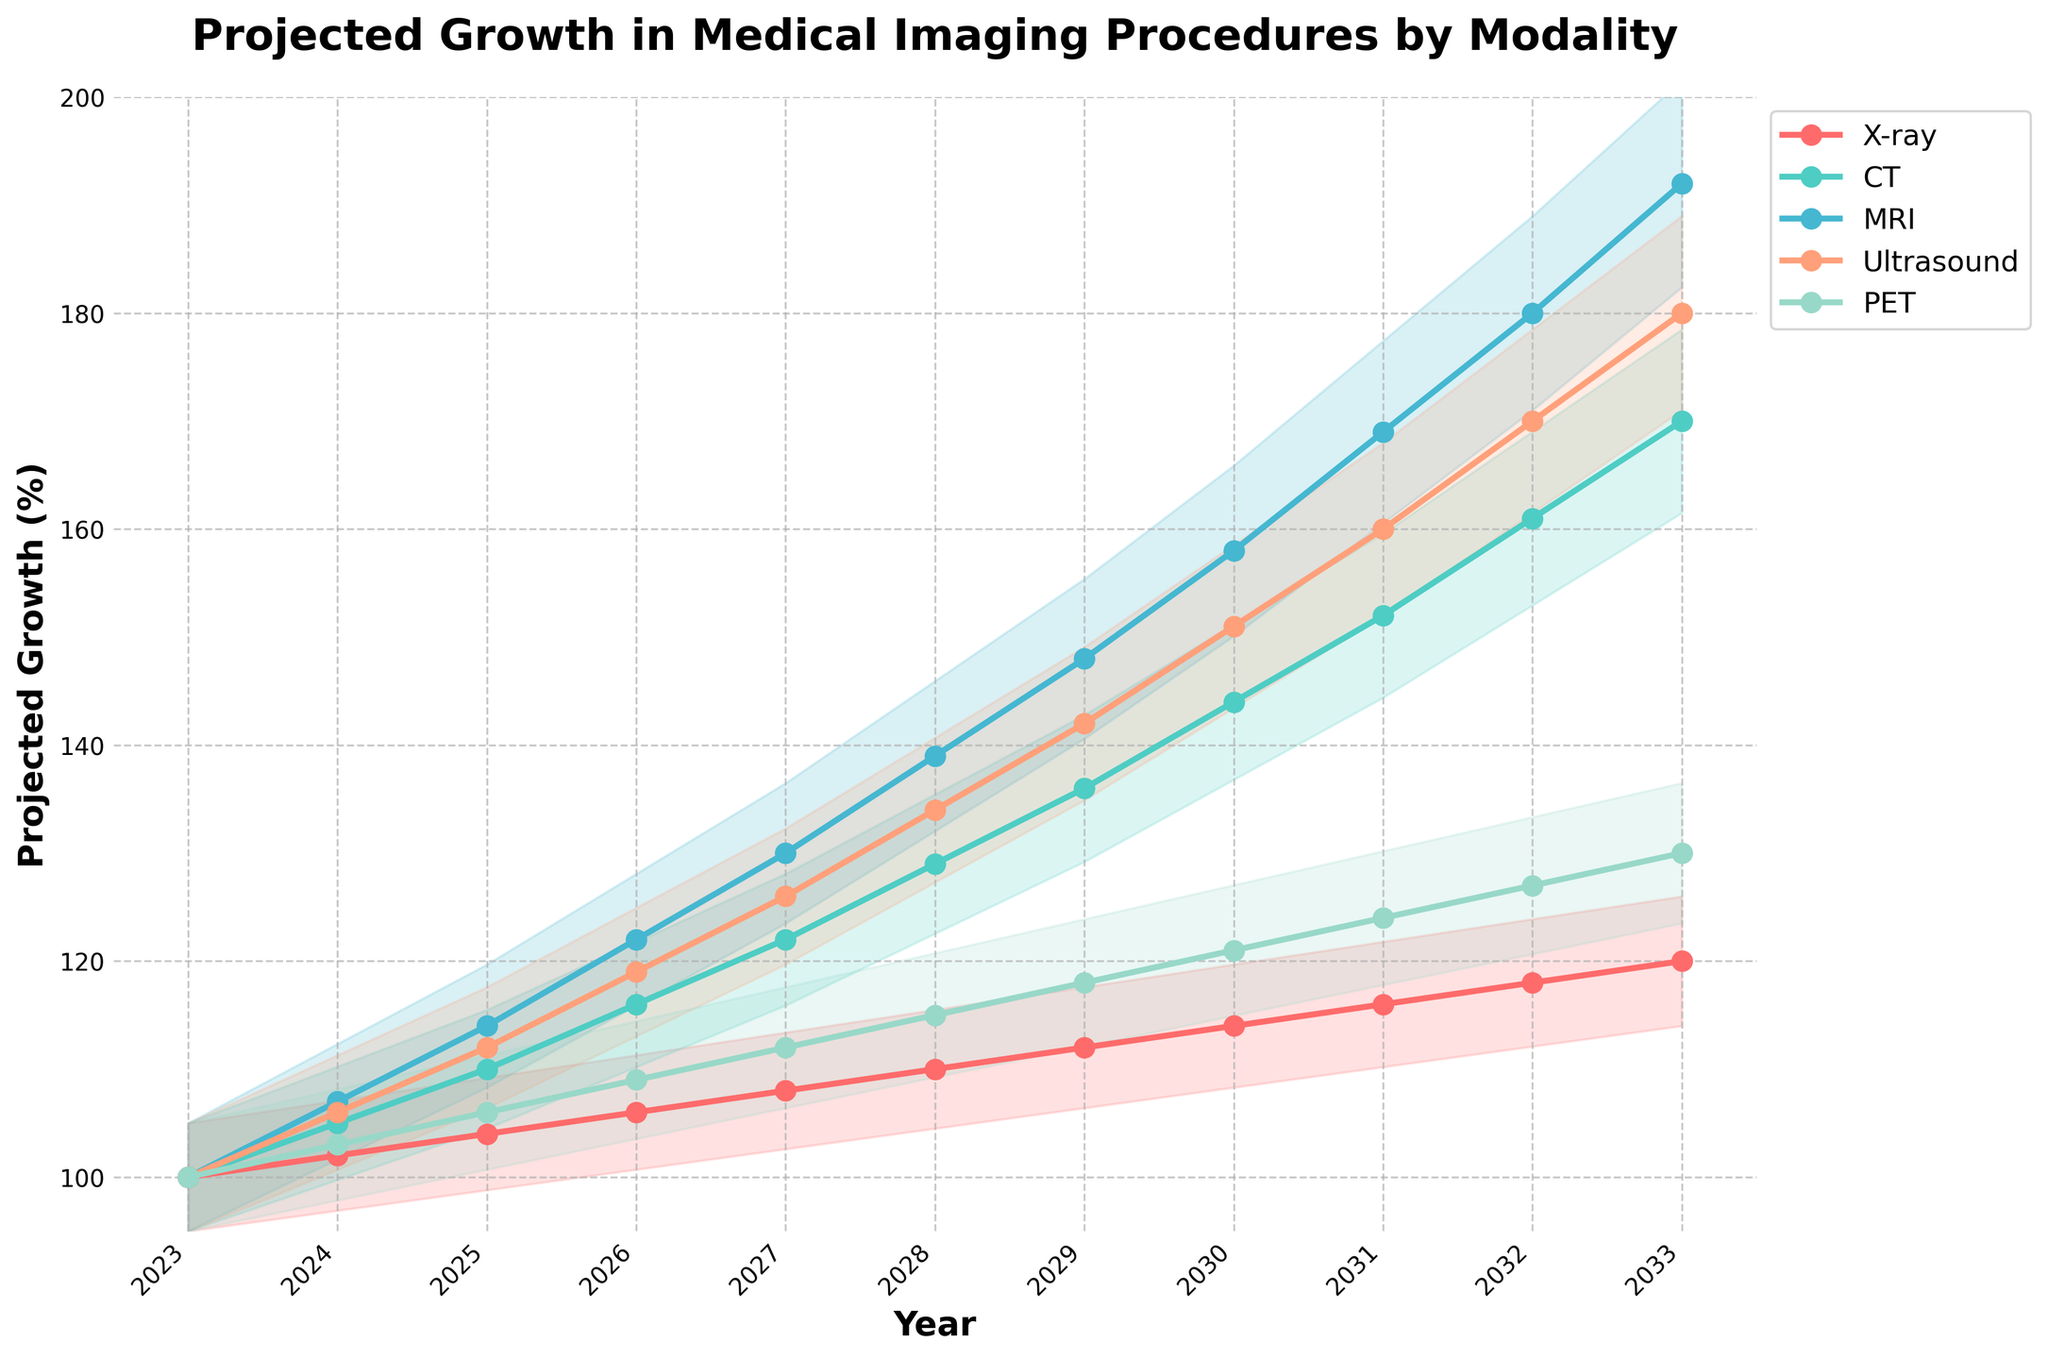What is the title of the chart? The title of the chart is displayed at the top and indicates the overall subject of the visualized data.
Answer: Projected Growth in Medical Imaging Procedures by Modality What is the projected percentage growth for MRI in 2028? Look at the MRI line (blue color) and find the value for the year 2028 on the x-axis.
Answer: 139% Which modality is projected to have the highest growth in 2033? Compare the endpoints of all the lines in the chart for the year 2033. The line with the highest value indicates the modality with the highest growth.
Answer: MRI How do the projected growth rates of X-ray and PET modalities compare in 2025? Locate the points of X-ray and PET for the year 2025 and compare their values.
Answer: X-ray: 104%; PET: 106% Which modality shows the most consistent growth over the years 2023 to 2033? Evaluate all the modalities and find the one with the most linear and steady increase without major fluctuations.
Answer: X-ray Between which years does CT see the greatest increment in projected growth? Examine the CT values year by year, and identify the period where the difference between consecutive years is the highest.
Answer: 2028 to 2029 Which modality has the narrowest confidence interval band in 2030? Examine the filled areas (confidence intervals) for all modalities in 2030 and identify the modality with the smallest band.
Answer: Ultrasound 